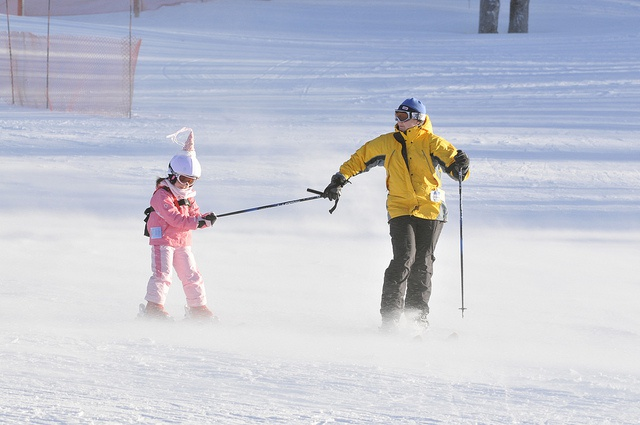Describe the objects in this image and their specific colors. I can see people in gray, olive, black, and lightgray tones, people in gray, lightgray, lightpink, darkgray, and violet tones, skis in gray, lightgray, and black tones, skis in lightgray, white, and gray tones, and skis in gray, lightgray, and black tones in this image. 